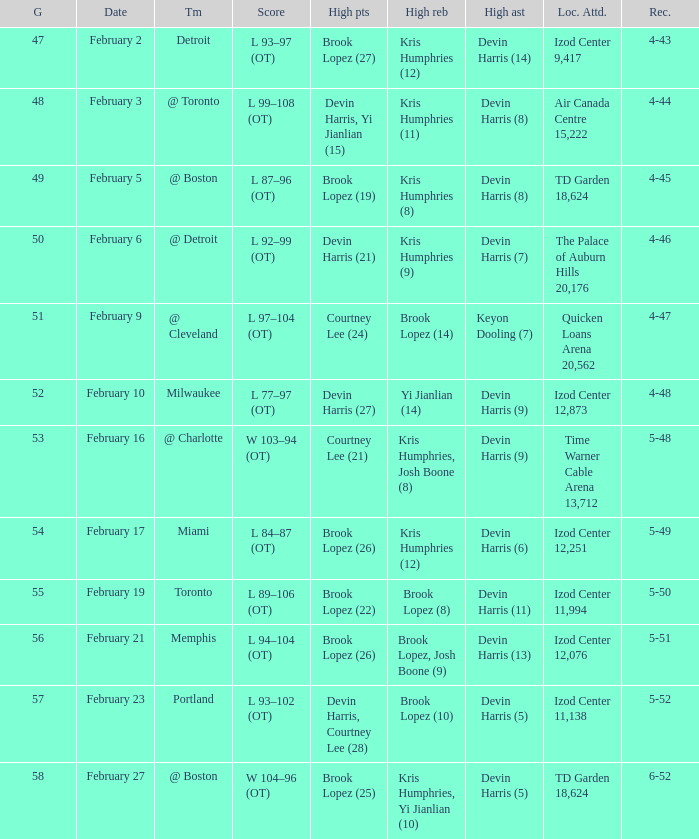Who achieved the most assists in the game that took place on february 9? Keyon Dooling (7). 